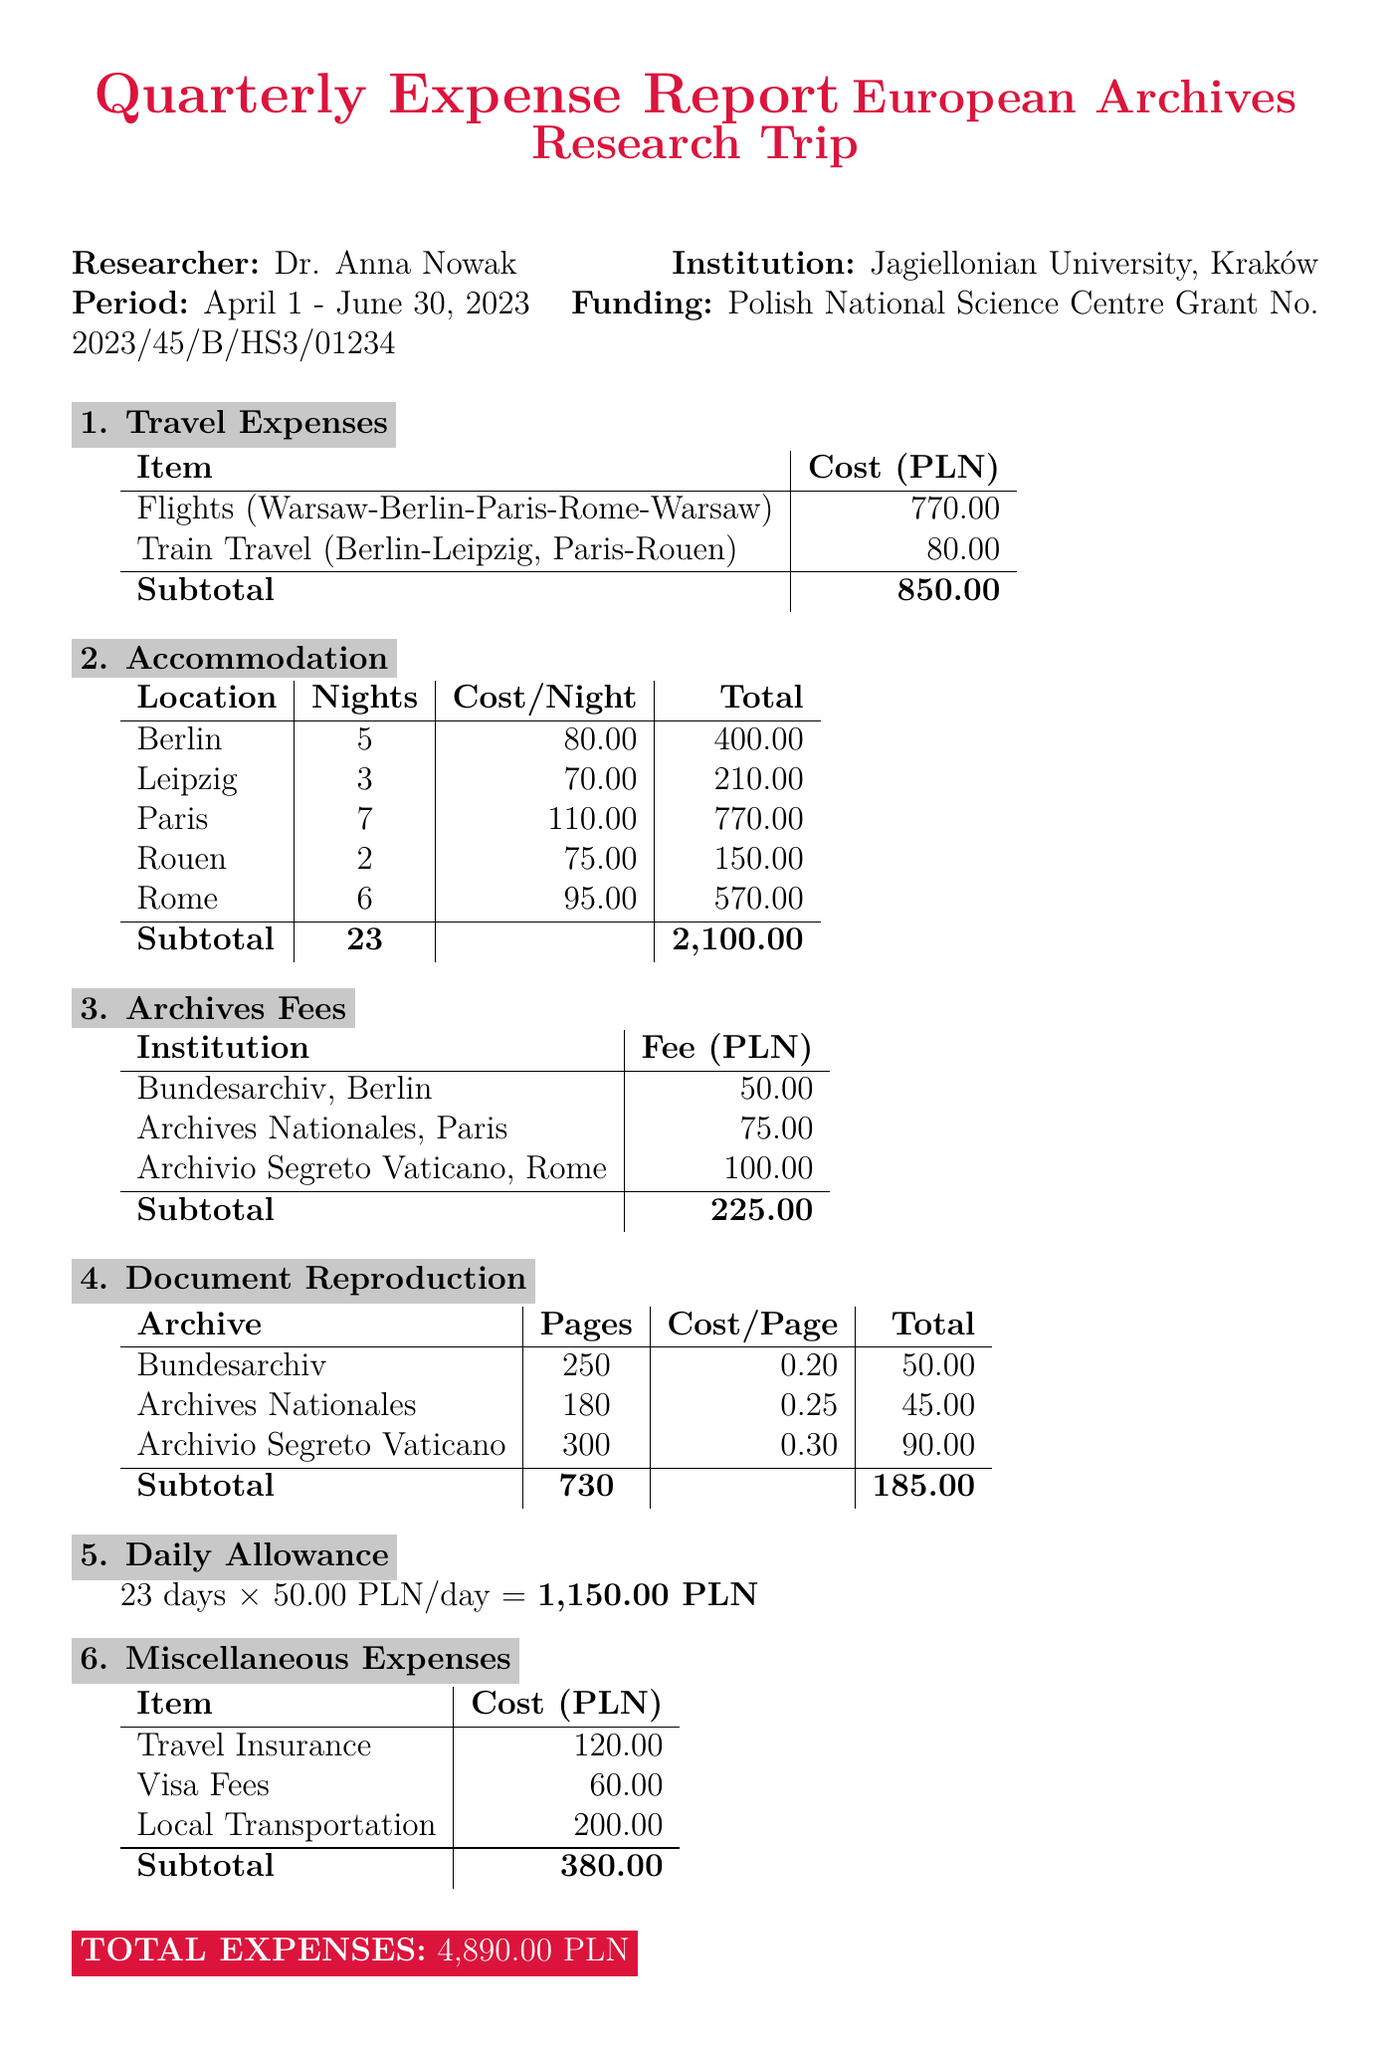What is the name of the researcher? The researcher's name is mentioned at the beginning of the report.
Answer: Dr. Anna Nowak What is the total cost for flights? The total cost for flights is calculated by summing the individual flight costs listed in the travel expenses section.
Answer: 770.00 PLN How many nights did the researcher stay in Paris? The number of nights in Paris is specified in the accommodation expenses section of the report.
Answer: 7 What is the fee for the Archives Nationales in Paris? The fee for accessing the Archives Nationales is listed in the archives fees section.
Answer: 75.00 PLN What is the total expense for daily allowance? The daily allowance total is calculated by multiplying the daily amount by the total days specified in the document.
Answer: 1,150.00 PLN How much was spent on document reproduction at the Archivio Segreto Vaticano? The reproduction cost is detailed in the document reproduction section, which lists the cost per page and the number of pages.
Answer: 90.00 PLN What is the total number of days included in the report period? The report period from April 1 to June 30 contains a specific number of days.
Answer: 90 What is the funding source for this research trip? The funding source is stated at the beginning of the report as the financial support for the trip.
Answer: Polish National Science Centre Grant No. 2023/45/B/HS3/01234 What are the miscellaneous expenses listed in the report? The miscellaneous expenses are outlined with specific items and costs within the corresponding section of the report.
Answer: Travel Insurance, Visa Fees, Local Transportation 